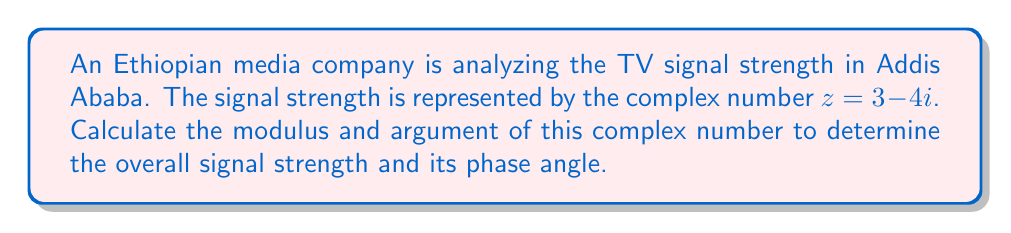Solve this math problem. To find the modulus and argument of the complex number $z = 3 - 4i$, we'll follow these steps:

1. Modulus calculation:
   The modulus (magnitude) of a complex number $z = a + bi$ is given by:
   $$ |z| = \sqrt{a^2 + b^2} $$
   
   For $z = 3 - 4i$:
   $$ |z| = \sqrt{3^2 + (-4)^2} = \sqrt{9 + 16} = \sqrt{25} = 5 $$

2. Argument calculation:
   The argument (phase angle) of a complex number is given by:
   $$ \arg(z) = \tan^{-1}\left(\frac{b}{a}\right) $$
   
   However, we need to be careful with the quadrant. Since the real part is positive and the imaginary part is negative, we're in the fourth quadrant.
   
   $$ \arg(z) = \tan^{-1}\left(\frac{-4}{3}\right) $$
   $$ \arg(z) = -53.13^\circ $$
   
   To express this in the standard range $[-180^\circ, 180^\circ)$, we keep it as is.

   Alternatively, in radians:
   $$ \arg(z) = -0.927 \text{ radians} $$

Thus, the TV signal strength has a magnitude of 5 units and a phase angle of -53.13° or -0.927 radians.
Answer: Modulus: 5, Argument: -53.13° or -0.927 radians 